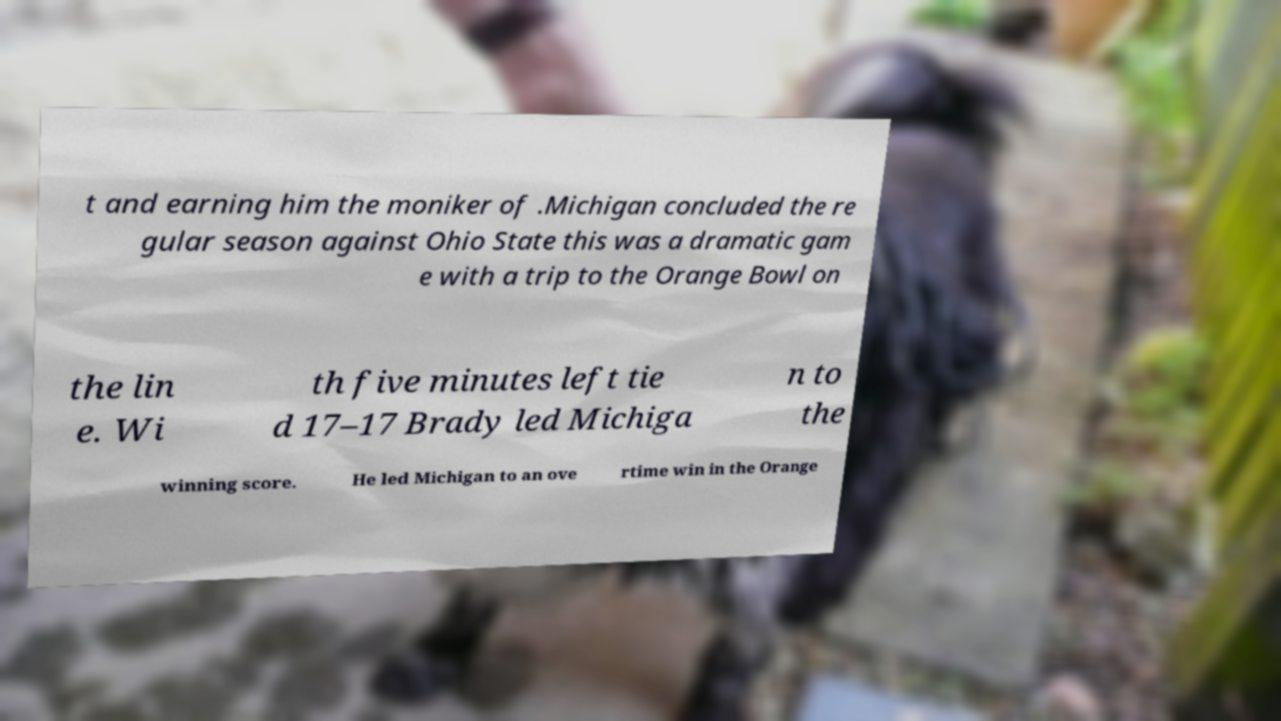Please identify and transcribe the text found in this image. t and earning him the moniker of .Michigan concluded the re gular season against Ohio State this was a dramatic gam e with a trip to the Orange Bowl on the lin e. Wi th five minutes left tie d 17–17 Brady led Michiga n to the winning score. He led Michigan to an ove rtime win in the Orange 